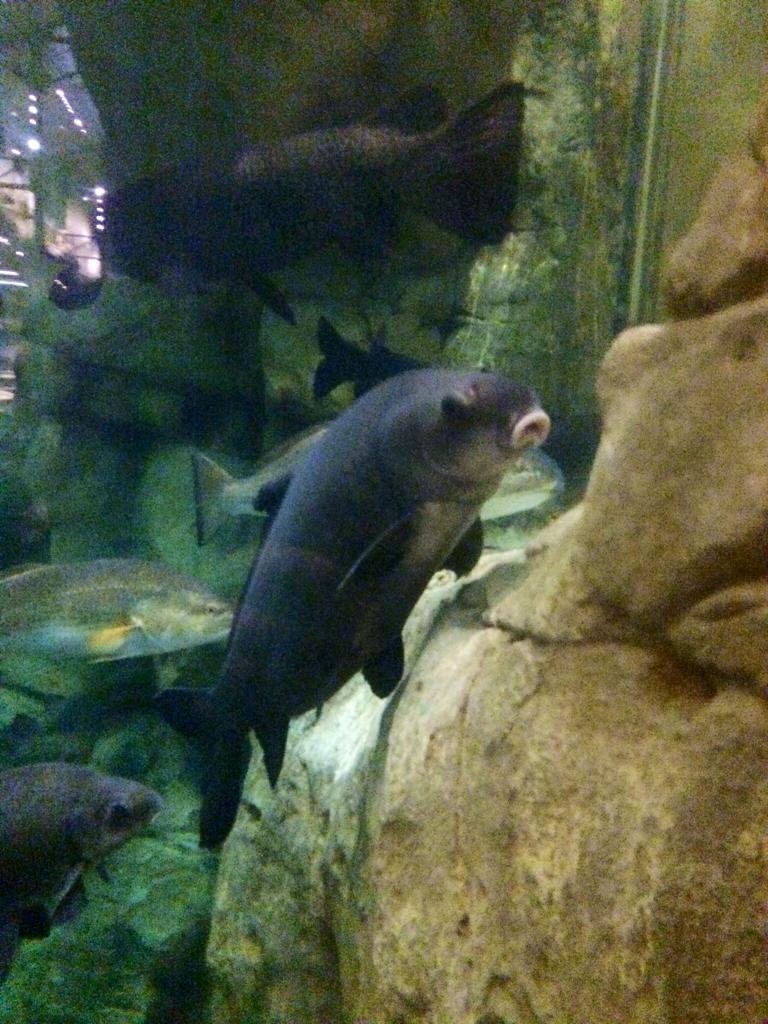What type of animals are in the image? There are fishes in the image. Where are the fishes located? The fishes are in water. What can be seen around the water in the image? There are stones around the water in the image. What type of church can be seen in the image? There is no church present in the image; it features fishes in water with stones around it. What nerve is responsible for controlling the movement of the fishes in the image? There is no need to discuss nerves or their functions in this context, as the image is focused on the visual representation of fishes in water with stones around it. 